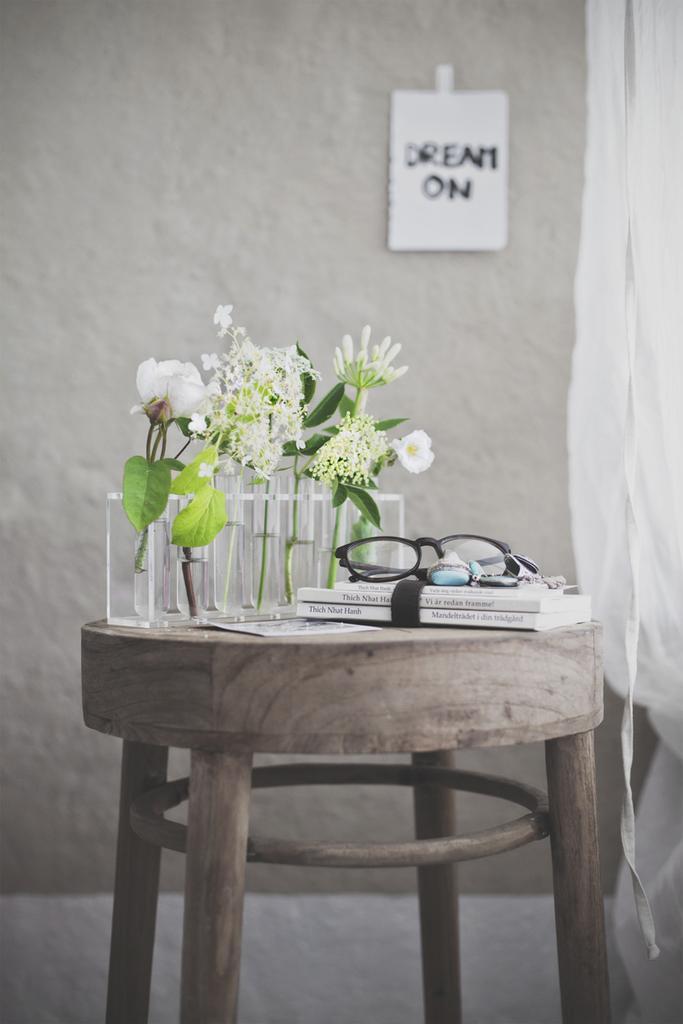Can you describe this image briefly? There is a stool. There is a glass ,flower vase,book and spectacle on a stool. We can see in the background beautiful wall ,poster and curtain is there. 